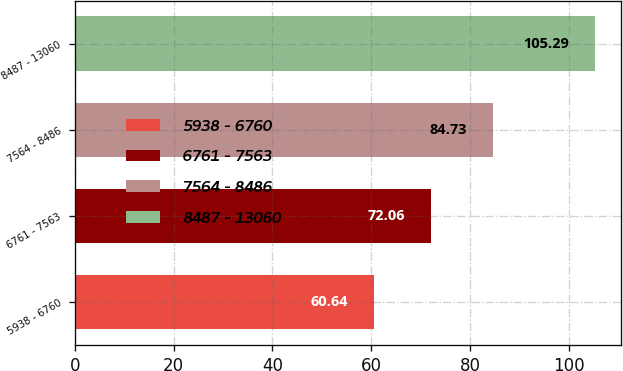Convert chart to OTSL. <chart><loc_0><loc_0><loc_500><loc_500><bar_chart><fcel>5938 - 6760<fcel>6761 - 7563<fcel>7564 - 8486<fcel>8487 - 13060<nl><fcel>60.64<fcel>72.06<fcel>84.73<fcel>105.29<nl></chart> 